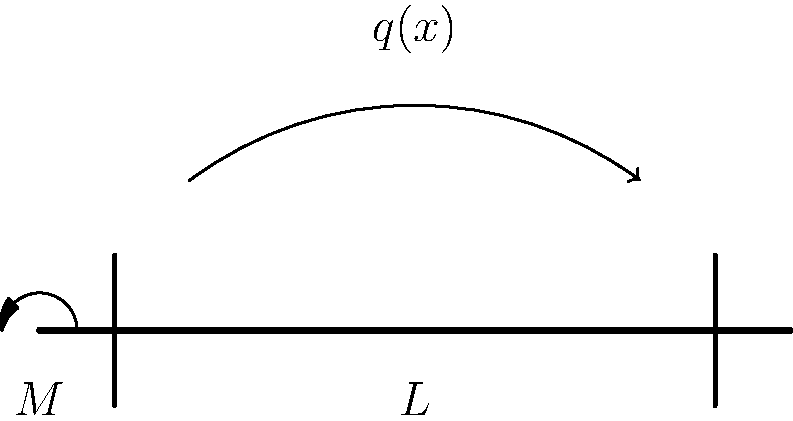A simply supported beam of length $L$ is subjected to a non-uniform distributed load $q(x)$ and a moment $M$ at the left end. Determine the expression for the maximum bending stress $\sigma_{max}$ in terms of the beam's moment of inertia $I$, the distance from the neutral axis to the outermost fiber $y$, and the maximum bending moment $M_{max}$. To find the maximum bending stress, we'll follow these steps:

1) Recall the general equation for bending stress:
   $$\sigma = \frac{My}{I}$$
   where $M$ is the bending moment, $y$ is the distance from the neutral axis, and $I$ is the moment of inertia.

2) The maximum stress will occur at the point of maximum bending moment $M_{max}$ and at the outermost fiber (maximum $y$).

3) Substituting these values into the bending stress equation:
   $$\sigma_{max} = \frac{M_{max}y_{max}}{I}$$

4) Note that $y_{max}$ is typically denoted as just $y$ in beam problems, representing the distance from the neutral axis to the outermost fiber.

5) Therefore, the final expression for maximum bending stress is:
   $$\sigma_{max} = \frac{M_{max}y}{I}$$

This equation gives the maximum bending stress in the beam under the given loading conditions.
Answer: $\sigma_{max} = \frac{M_{max}y}{I}$ 